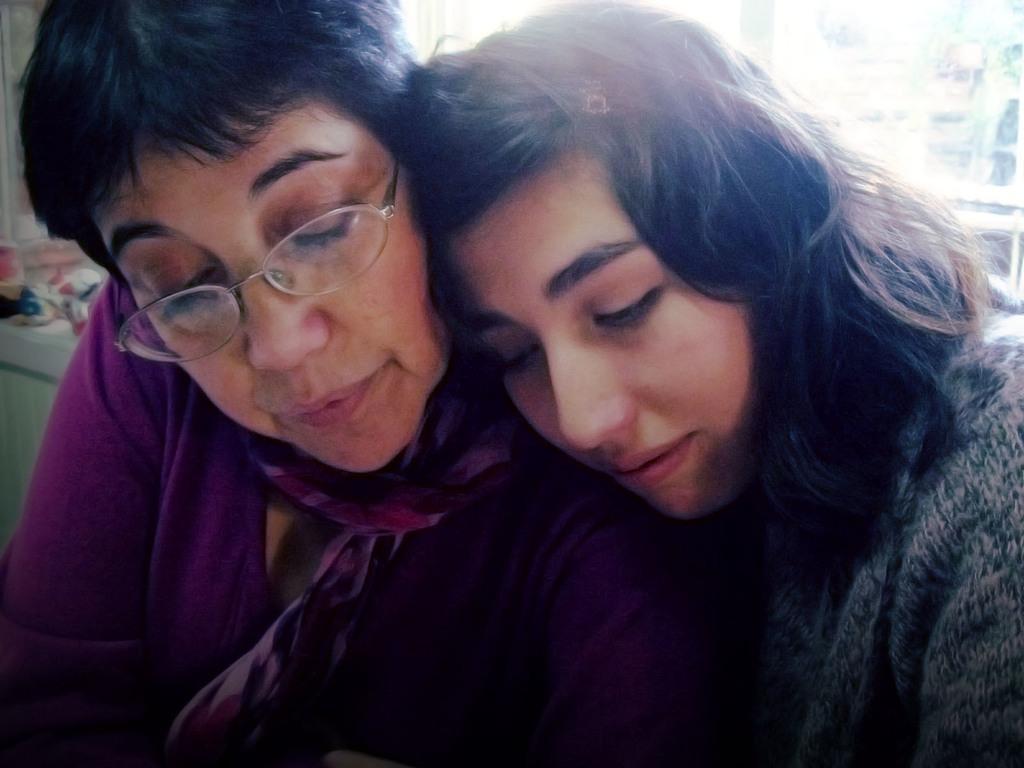In one or two sentences, can you explain what this image depicts? In this image we can see two ladies, there are some objects on the table, and the background is blurred. 